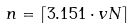<formula> <loc_0><loc_0><loc_500><loc_500>n = \left \lceil 3 . 1 5 1 \cdot v N \right \rceil</formula> 